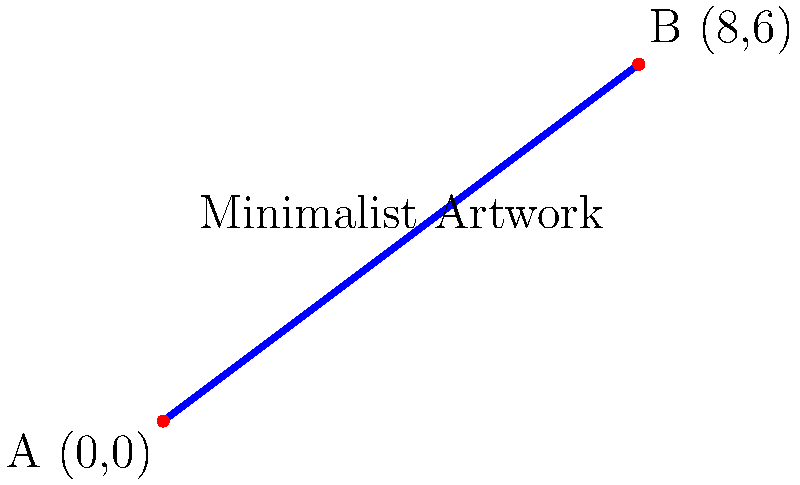A minimalist artwork is represented by a line segment from point A (0,0) to point B (8,6) on a coordinate plane. Find the midpoint of this line segment, which represents the center of the artwork's composition. Express your answer as an ordered pair $(x,y)$. To find the midpoint of a line segment, we can use the midpoint formula:

$$(x_{\text{midpoint}}, y_{\text{midpoint}}) = \left(\frac{x_1 + x_2}{2}, \frac{y_1 + y_2}{2}\right)$$

Where $(x_1, y_1)$ are the coordinates of the first point and $(x_2, y_2)$ are the coordinates of the second point.

Given:
Point A: $(0, 0)$
Point B: $(8, 6)$

Step 1: Calculate the x-coordinate of the midpoint
$$x_{\text{midpoint}} = \frac{x_1 + x_2}{2} = \frac{0 + 8}{2} = \frac{8}{2} = 4$$

Step 2: Calculate the y-coordinate of the midpoint
$$y_{\text{midpoint}} = \frac{y_1 + y_2}{2} = \frac{0 + 6}{2} = \frac{6}{2} = 3$$

Step 3: Combine the results into an ordered pair
The midpoint is $(4, 3)$

This point represents the center of the minimalist artwork's composition, balancing the visual elements on either side.
Answer: $(4, 3)$ 